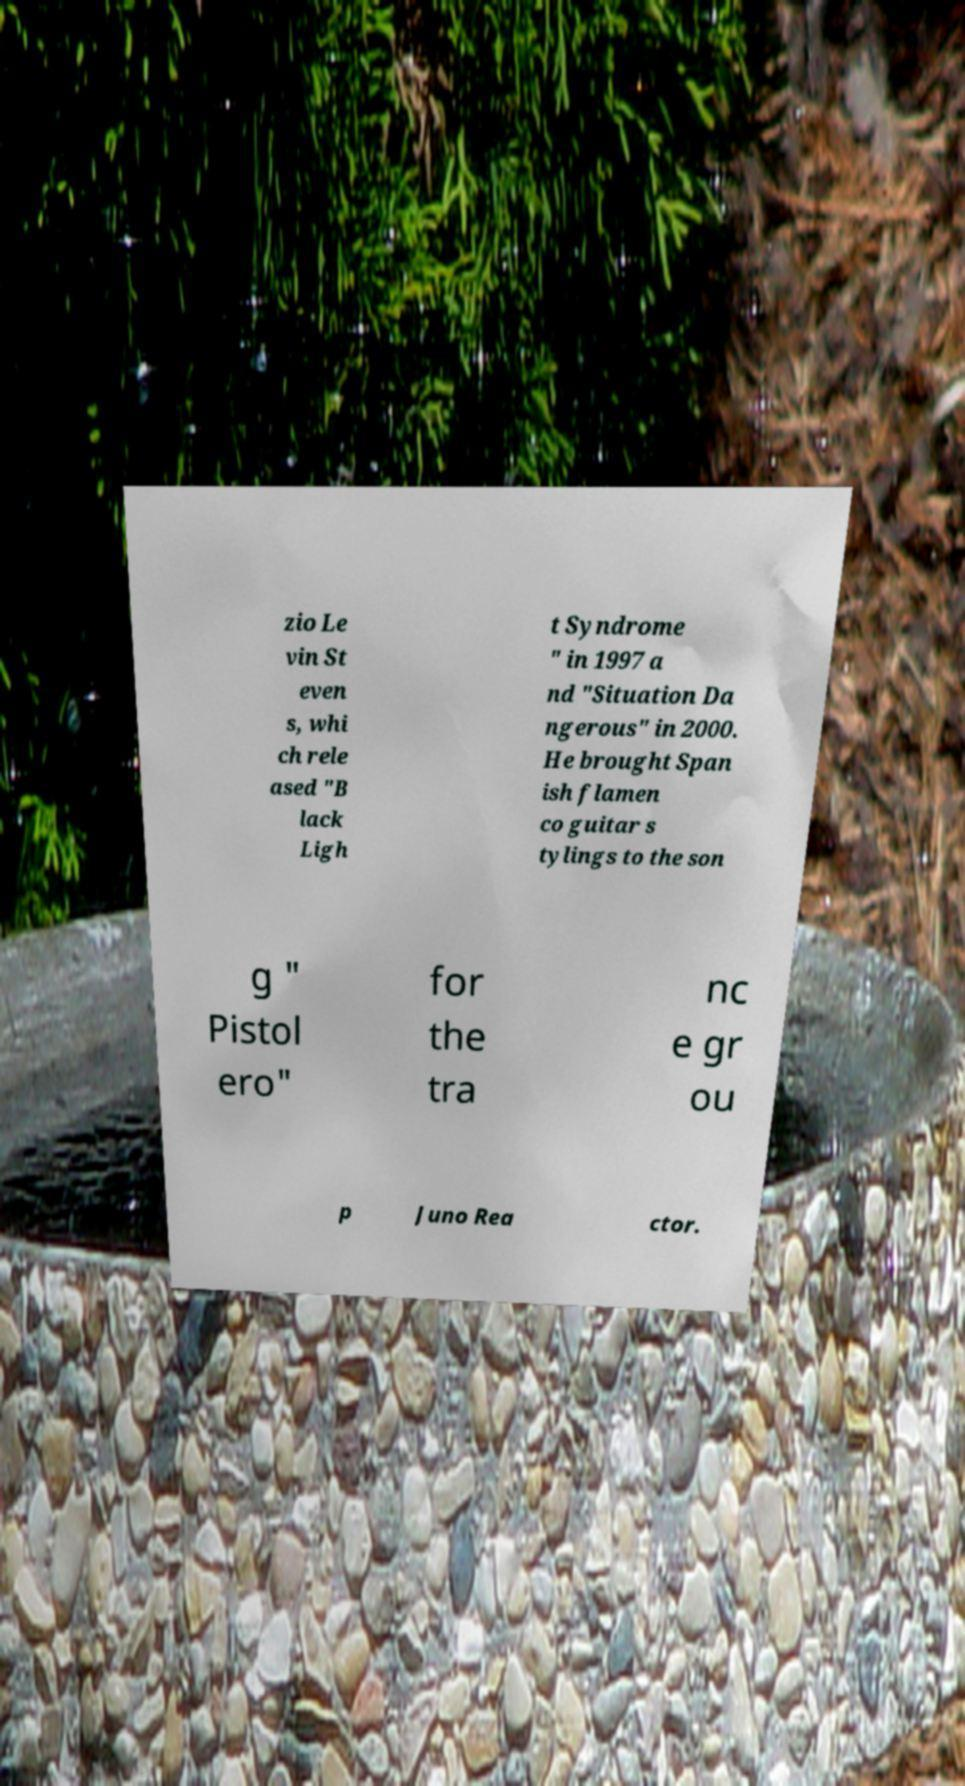I need the written content from this picture converted into text. Can you do that? zio Le vin St even s, whi ch rele ased "B lack Ligh t Syndrome " in 1997 a nd "Situation Da ngerous" in 2000. He brought Span ish flamen co guitar s tylings to the son g " Pistol ero" for the tra nc e gr ou p Juno Rea ctor. 